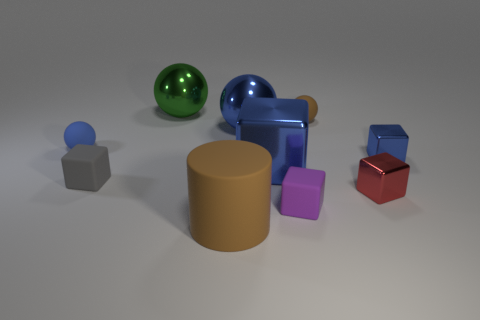What color is the block that is to the right of the green sphere and left of the purple matte object?
Offer a very short reply. Blue. Are there any large metallic things of the same color as the large cube?
Offer a very short reply. Yes. Do the big thing that is in front of the red metallic object and the small blue thing that is to the left of the tiny blue shiny block have the same material?
Offer a very short reply. Yes. What size is the brown matte object behind the small purple block?
Your answer should be compact. Small. How big is the blue rubber thing?
Give a very brief answer. Small. There is a brown rubber thing that is in front of the small rubber sphere that is right of the small rubber ball that is on the left side of the green shiny object; what size is it?
Ensure brevity in your answer.  Large. Is there a green sphere made of the same material as the brown cylinder?
Your answer should be very brief. No. What is the shape of the green object?
Offer a terse response. Sphere. What is the color of the small block that is the same material as the small purple object?
Your answer should be compact. Gray. What number of red objects are shiny spheres or tiny rubber objects?
Your answer should be very brief. 0. 